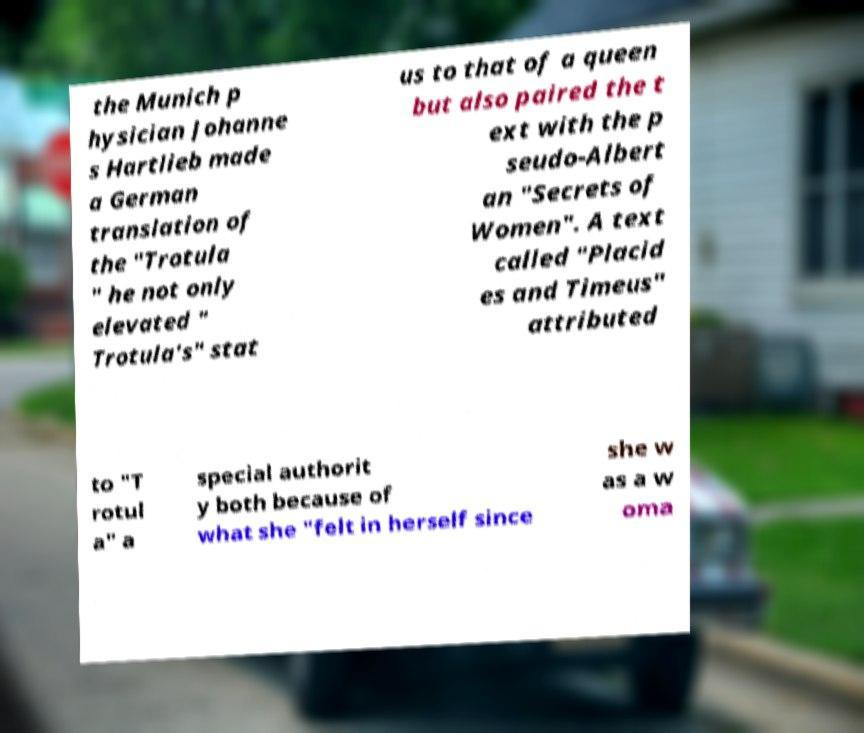Can you accurately transcribe the text from the provided image for me? the Munich p hysician Johanne s Hartlieb made a German translation of the "Trotula " he not only elevated " Trotula's" stat us to that of a queen but also paired the t ext with the p seudo-Albert an "Secrets of Women". A text called "Placid es and Timeus" attributed to "T rotul a" a special authorit y both because of what she "felt in herself since she w as a w oma 